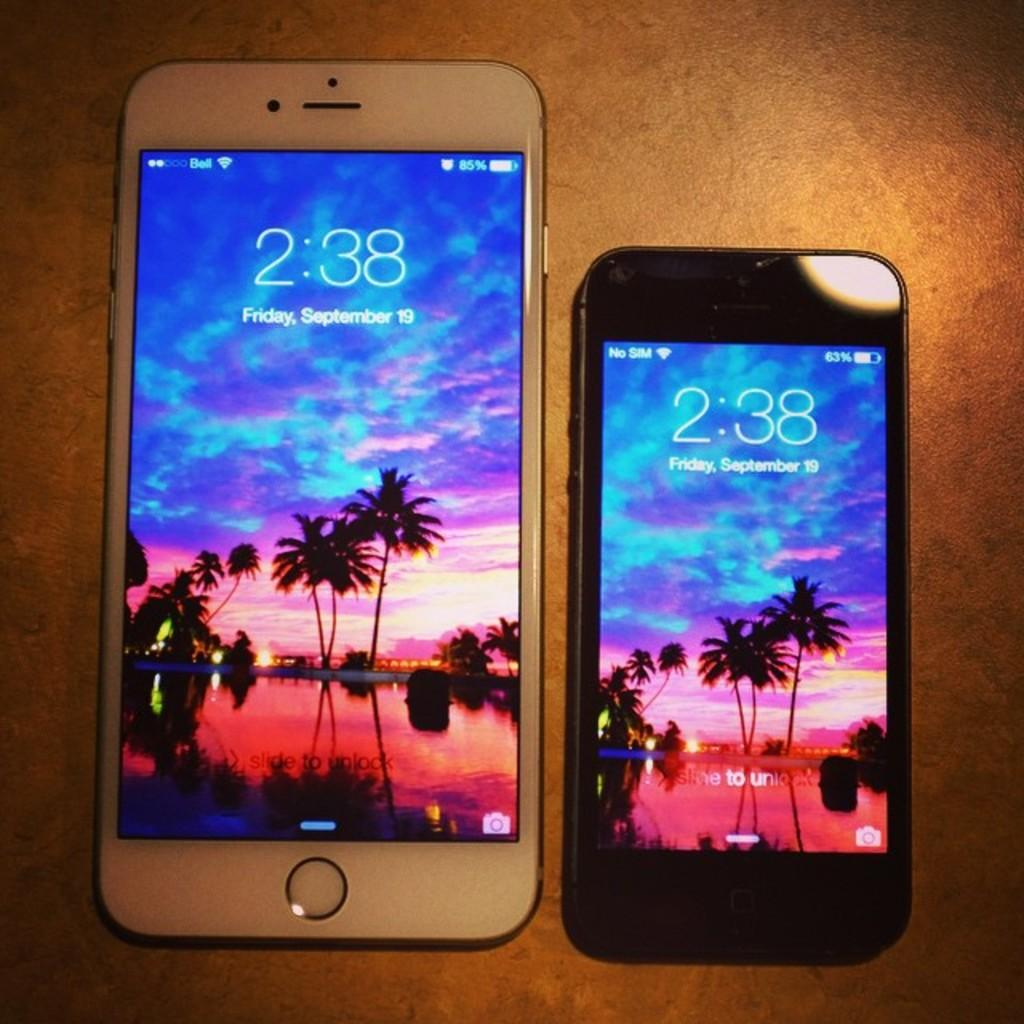<image>
Share a concise interpretation of the image provided. two iphones side to side on a table, the time 2:38 on September 19th 